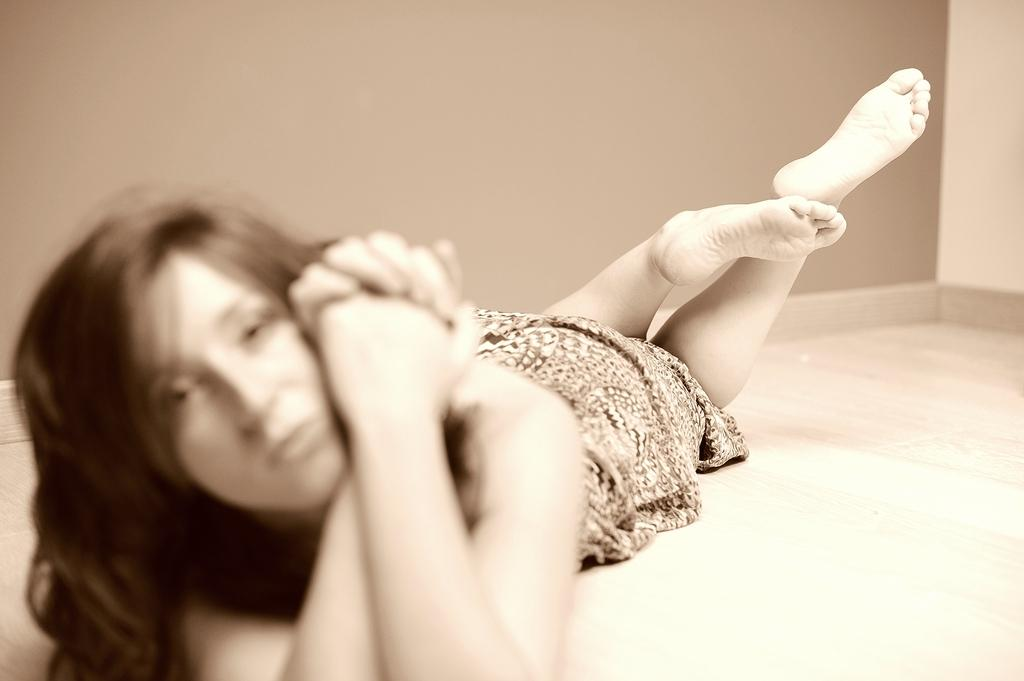Who is present in the image? There is a woman in the image. What is the woman doing in the image? The woman is lying on the floor. What can be seen behind the woman in the image? There is a wall visible in the image. What language is the woman speaking in the image? There is no indication of the woman speaking in the image, so it is not possible to determine the language. 